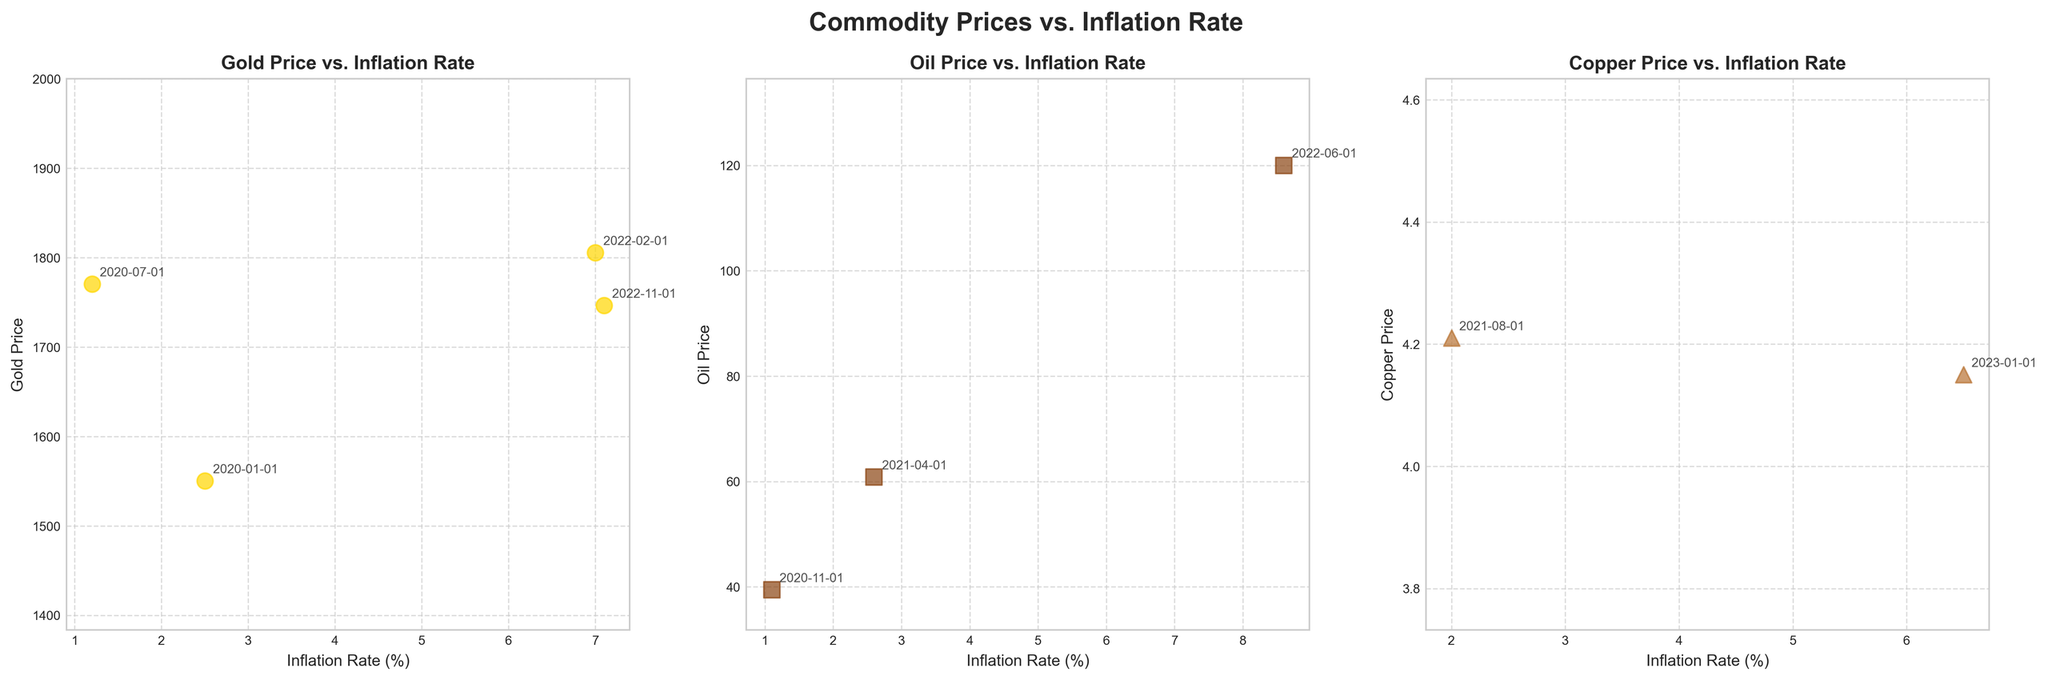What is the title of the figure? The title of the figure can be found at the top. It reads "Commodity Prices vs. Inflation Rate".
Answer: Commodity Prices vs. Inflation Rate How many subplots are there in the figure? By counting the individual plots within the main figure, you can see there are three subplots.
Answer: Three Which commodity shows the highest price and during which event? Look at the vertical axis (Price) of each subplot and locate the highest price point. The commodity is Oil with a price of 120.00 during the Russia-Ukraine Conflict.
Answer: Oil, Russia-Ukraine Conflict What is the inflation rate corresponding to the highest price of Gold? Check the Gold subplot for the highest price and read the corresponding point on the horizontal axis (Inflation Rate). The highest price of Gold is 1805.50, which corresponds to an inflation rate of 7.0%.
Answer: 7.0% Which commodity had the lowest price, and during which event did this occur? By examining the lowest points on the vertical axis of each subplot, you can see that Oil had the lowest price of 39.40 during the US Presidential Elections.
Answer: Oil, US Presidential Elections Which event corresponds to the highest inflation rate in the Copper subplot? Identify the highest point on the horizontal axis (Inflation Rate) in the Copper subplot. This point corresponds to the US Debt Ceiling Crisis with an inflation rate of 6.5%.
Answer: US Debt Ceiling Crisis What is the difference in price for Copper between the Supply Chain Disruptions and the US Debt Ceiling Crisis events? Check the points corresponding to the two events in the Copper subplot. The price for Copper during Supply Chain Disruptions is 4.21 and during the US Debt Ceiling Crisis is 4.15. The difference is 4.21 - 4.15 = 0.06.
Answer: 0.06 How many unique geopolitical events are mentioned in the Gold subplot? By reading the annotations for each data point in the Gold subplot, you can count five unique geopolitical events: US-Iran Tensions, COVID-19 Pandemic, Russia-Ukraine Conflict, US Stimulus Package, and China's Economic Slowdown.
Answer: Five Which commodity's plot shows the most events with inflation rates higher than 2.5%? Check the horizontal axis (Inflation Rate) for points higher than 2.5% in each subplot. The Gold subplot has three events (Russia-Ukraine Conflict, US Stimulus Package, and China's Economic Slowdown) with inflation rates higher than 2.5%.
Answer: Gold 